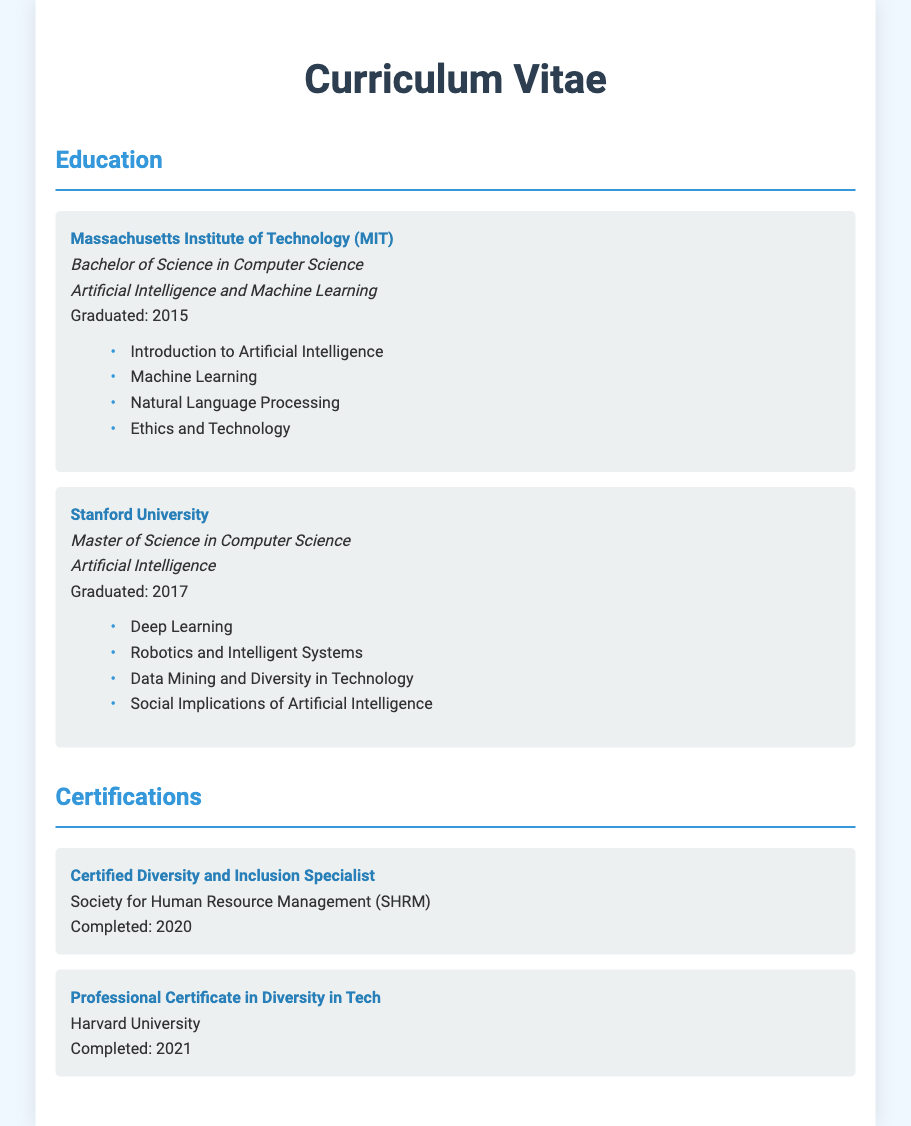What degree did the individual earn at MIT? The individual earned a Bachelor of Science in Computer Science at MIT.
Answer: Bachelor of Science in Computer Science What was the major focus of the Master’s degree? The major focus of the Master’s degree was Artificial Intelligence.
Answer: Artificial Intelligence Which course at Stanford covers technology diversity? The course at Stanford that covers technology diversity is Data Mining and Diversity in Technology.
Answer: Data Mining and Diversity in Technology When did the individual complete the Professional Certificate in Diversity in Tech? The individual completed the Professional Certificate in Diversity in Tech in 2021.
Answer: 2021 What certification was issued by the Society for Human Resource Management? The certification issued by the Society for Human Resource Management is Certified Diversity and Inclusion Specialist.
Answer: Certified Diversity and Inclusion Specialist What year did the individual graduate from Stanford University? The individual graduated from Stanford University in 2017.
Answer: 2017 Which institution did the individual attend for their Bachelor’s degree? The individual attended Massachusetts Institute of Technology for their Bachelor’s degree.
Answer: Massachusetts Institute of Technology What is one course listed under the bachelor's degree? One course listed under the bachelor's degree is Introduction to Artificial Intelligence.
Answer: Introduction to Artificial Intelligence 